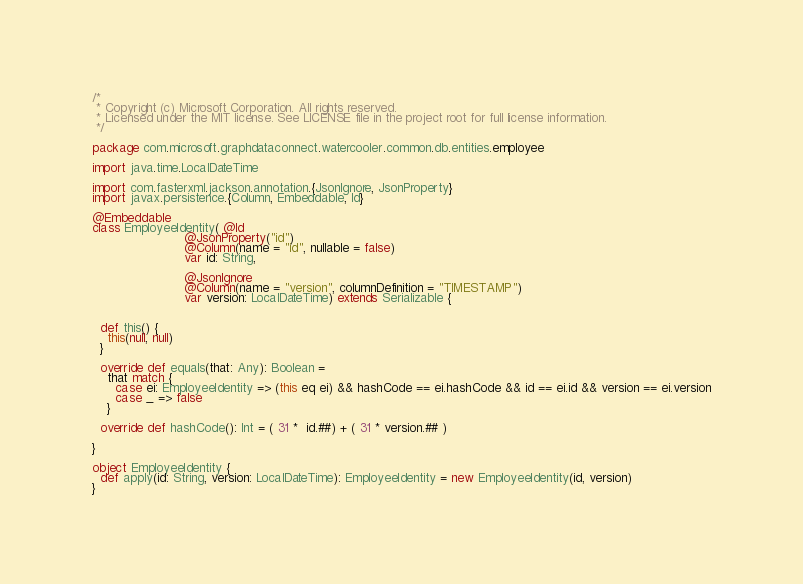Convert code to text. <code><loc_0><loc_0><loc_500><loc_500><_Scala_>/*
 * Copyright (c) Microsoft Corporation. All rights reserved.
 * Licensed under the MIT license. See LICENSE file in the project root for full license information.
 */

package com.microsoft.graphdataconnect.watercooler.common.db.entities.employee

import java.time.LocalDateTime

import com.fasterxml.jackson.annotation.{JsonIgnore, JsonProperty}
import javax.persistence.{Column, Embeddable, Id}

@Embeddable
class EmployeeIdentity( @Id
                        @JsonProperty("id")
                        @Column(name = "id", nullable = false)
                        var id: String,

                        @JsonIgnore
                        @Column(name = "version", columnDefinition = "TIMESTAMP")
                        var version: LocalDateTime) extends Serializable {


  def this() {
    this(null, null)
  }

  override def equals(that: Any): Boolean =
    that match {
      case ei: EmployeeIdentity => (this eq ei) && hashCode == ei.hashCode && id == ei.id && version == ei.version
      case _ => false
    }

  override def hashCode(): Int = ( 31 *  id.##) + ( 31 * version.## )

}

object EmployeeIdentity {
  def apply(id: String, version: LocalDateTime): EmployeeIdentity = new EmployeeIdentity(id, version)
}
</code> 